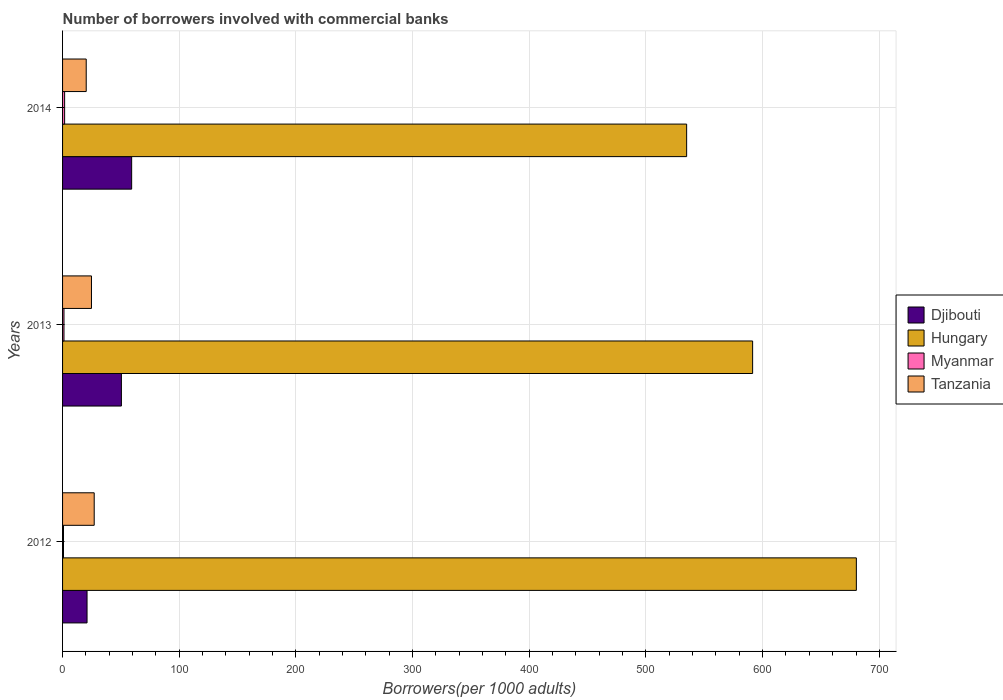How many bars are there on the 1st tick from the top?
Make the answer very short. 4. How many bars are there on the 3rd tick from the bottom?
Make the answer very short. 4. What is the label of the 1st group of bars from the top?
Your answer should be very brief. 2014. What is the number of borrowers involved with commercial banks in Myanmar in 2013?
Make the answer very short. 1.22. Across all years, what is the maximum number of borrowers involved with commercial banks in Djibouti?
Provide a succinct answer. 59.22. Across all years, what is the minimum number of borrowers involved with commercial banks in Tanzania?
Make the answer very short. 20.27. In which year was the number of borrowers involved with commercial banks in Tanzania maximum?
Provide a succinct answer. 2012. In which year was the number of borrowers involved with commercial banks in Djibouti minimum?
Your response must be concise. 2012. What is the total number of borrowers involved with commercial banks in Myanmar in the graph?
Your answer should be compact. 3.78. What is the difference between the number of borrowers involved with commercial banks in Tanzania in 2012 and that in 2014?
Your response must be concise. 6.85. What is the difference between the number of borrowers involved with commercial banks in Hungary in 2013 and the number of borrowers involved with commercial banks in Djibouti in 2012?
Your answer should be very brief. 570.44. What is the average number of borrowers involved with commercial banks in Tanzania per year?
Offer a terse response. 24.05. In the year 2013, what is the difference between the number of borrowers involved with commercial banks in Hungary and number of borrowers involved with commercial banks in Djibouti?
Offer a terse response. 540.99. What is the ratio of the number of borrowers involved with commercial banks in Djibouti in 2013 to that in 2014?
Offer a very short reply. 0.85. Is the number of borrowers involved with commercial banks in Hungary in 2013 less than that in 2014?
Your response must be concise. No. Is the difference between the number of borrowers involved with commercial banks in Hungary in 2012 and 2013 greater than the difference between the number of borrowers involved with commercial banks in Djibouti in 2012 and 2013?
Offer a terse response. Yes. What is the difference between the highest and the second highest number of borrowers involved with commercial banks in Hungary?
Offer a terse response. 88.9. What is the difference between the highest and the lowest number of borrowers involved with commercial banks in Djibouti?
Provide a short and direct response. 38.24. In how many years, is the number of borrowers involved with commercial banks in Hungary greater than the average number of borrowers involved with commercial banks in Hungary taken over all years?
Offer a very short reply. 1. Is the sum of the number of borrowers involved with commercial banks in Tanzania in 2012 and 2013 greater than the maximum number of borrowers involved with commercial banks in Hungary across all years?
Offer a very short reply. No. Is it the case that in every year, the sum of the number of borrowers involved with commercial banks in Hungary and number of borrowers involved with commercial banks in Myanmar is greater than the sum of number of borrowers involved with commercial banks in Djibouti and number of borrowers involved with commercial banks in Tanzania?
Offer a very short reply. Yes. What does the 2nd bar from the top in 2013 represents?
Give a very brief answer. Myanmar. What does the 3rd bar from the bottom in 2014 represents?
Provide a succinct answer. Myanmar. Is it the case that in every year, the sum of the number of borrowers involved with commercial banks in Myanmar and number of borrowers involved with commercial banks in Tanzania is greater than the number of borrowers involved with commercial banks in Hungary?
Keep it short and to the point. No. How many bars are there?
Give a very brief answer. 12. Are all the bars in the graph horizontal?
Offer a terse response. Yes. What is the difference between two consecutive major ticks on the X-axis?
Your answer should be compact. 100. Are the values on the major ticks of X-axis written in scientific E-notation?
Provide a succinct answer. No. Where does the legend appear in the graph?
Ensure brevity in your answer.  Center right. How are the legend labels stacked?
Keep it short and to the point. Vertical. What is the title of the graph?
Your answer should be compact. Number of borrowers involved with commercial banks. Does "Haiti" appear as one of the legend labels in the graph?
Provide a succinct answer. No. What is the label or title of the X-axis?
Offer a terse response. Borrowers(per 1000 adults). What is the Borrowers(per 1000 adults) in Djibouti in 2012?
Your answer should be compact. 20.98. What is the Borrowers(per 1000 adults) of Hungary in 2012?
Ensure brevity in your answer.  680.32. What is the Borrowers(per 1000 adults) of Myanmar in 2012?
Your answer should be compact. 0.8. What is the Borrowers(per 1000 adults) of Tanzania in 2012?
Your response must be concise. 27.12. What is the Borrowers(per 1000 adults) in Djibouti in 2013?
Keep it short and to the point. 50.43. What is the Borrowers(per 1000 adults) of Hungary in 2013?
Offer a terse response. 591.42. What is the Borrowers(per 1000 adults) of Myanmar in 2013?
Offer a very short reply. 1.22. What is the Borrowers(per 1000 adults) of Tanzania in 2013?
Offer a very short reply. 24.77. What is the Borrowers(per 1000 adults) in Djibouti in 2014?
Your answer should be very brief. 59.22. What is the Borrowers(per 1000 adults) of Hungary in 2014?
Make the answer very short. 534.85. What is the Borrowers(per 1000 adults) in Myanmar in 2014?
Your response must be concise. 1.77. What is the Borrowers(per 1000 adults) in Tanzania in 2014?
Provide a short and direct response. 20.27. Across all years, what is the maximum Borrowers(per 1000 adults) in Djibouti?
Your response must be concise. 59.22. Across all years, what is the maximum Borrowers(per 1000 adults) of Hungary?
Provide a short and direct response. 680.32. Across all years, what is the maximum Borrowers(per 1000 adults) in Myanmar?
Keep it short and to the point. 1.77. Across all years, what is the maximum Borrowers(per 1000 adults) in Tanzania?
Ensure brevity in your answer.  27.12. Across all years, what is the minimum Borrowers(per 1000 adults) of Djibouti?
Offer a terse response. 20.98. Across all years, what is the minimum Borrowers(per 1000 adults) in Hungary?
Provide a succinct answer. 534.85. Across all years, what is the minimum Borrowers(per 1000 adults) in Myanmar?
Your response must be concise. 0.8. Across all years, what is the minimum Borrowers(per 1000 adults) of Tanzania?
Your answer should be very brief. 20.27. What is the total Borrowers(per 1000 adults) of Djibouti in the graph?
Keep it short and to the point. 130.63. What is the total Borrowers(per 1000 adults) of Hungary in the graph?
Your answer should be compact. 1806.59. What is the total Borrowers(per 1000 adults) in Myanmar in the graph?
Provide a short and direct response. 3.78. What is the total Borrowers(per 1000 adults) in Tanzania in the graph?
Provide a short and direct response. 72.15. What is the difference between the Borrowers(per 1000 adults) in Djibouti in 2012 and that in 2013?
Provide a succinct answer. -29.45. What is the difference between the Borrowers(per 1000 adults) of Hungary in 2012 and that in 2013?
Your answer should be compact. 88.9. What is the difference between the Borrowers(per 1000 adults) in Myanmar in 2012 and that in 2013?
Offer a terse response. -0.42. What is the difference between the Borrowers(per 1000 adults) of Tanzania in 2012 and that in 2013?
Make the answer very short. 2.35. What is the difference between the Borrowers(per 1000 adults) of Djibouti in 2012 and that in 2014?
Your response must be concise. -38.24. What is the difference between the Borrowers(per 1000 adults) of Hungary in 2012 and that in 2014?
Your answer should be very brief. 145.46. What is the difference between the Borrowers(per 1000 adults) of Myanmar in 2012 and that in 2014?
Offer a very short reply. -0.97. What is the difference between the Borrowers(per 1000 adults) of Tanzania in 2012 and that in 2014?
Provide a succinct answer. 6.85. What is the difference between the Borrowers(per 1000 adults) of Djibouti in 2013 and that in 2014?
Ensure brevity in your answer.  -8.79. What is the difference between the Borrowers(per 1000 adults) in Hungary in 2013 and that in 2014?
Provide a succinct answer. 56.56. What is the difference between the Borrowers(per 1000 adults) of Myanmar in 2013 and that in 2014?
Provide a short and direct response. -0.55. What is the difference between the Borrowers(per 1000 adults) in Tanzania in 2013 and that in 2014?
Keep it short and to the point. 4.5. What is the difference between the Borrowers(per 1000 adults) in Djibouti in 2012 and the Borrowers(per 1000 adults) in Hungary in 2013?
Your answer should be very brief. -570.44. What is the difference between the Borrowers(per 1000 adults) in Djibouti in 2012 and the Borrowers(per 1000 adults) in Myanmar in 2013?
Give a very brief answer. 19.76. What is the difference between the Borrowers(per 1000 adults) in Djibouti in 2012 and the Borrowers(per 1000 adults) in Tanzania in 2013?
Ensure brevity in your answer.  -3.79. What is the difference between the Borrowers(per 1000 adults) in Hungary in 2012 and the Borrowers(per 1000 adults) in Myanmar in 2013?
Offer a terse response. 679.1. What is the difference between the Borrowers(per 1000 adults) in Hungary in 2012 and the Borrowers(per 1000 adults) in Tanzania in 2013?
Provide a short and direct response. 655.55. What is the difference between the Borrowers(per 1000 adults) of Myanmar in 2012 and the Borrowers(per 1000 adults) of Tanzania in 2013?
Provide a succinct answer. -23.97. What is the difference between the Borrowers(per 1000 adults) of Djibouti in 2012 and the Borrowers(per 1000 adults) of Hungary in 2014?
Your answer should be compact. -513.88. What is the difference between the Borrowers(per 1000 adults) of Djibouti in 2012 and the Borrowers(per 1000 adults) of Myanmar in 2014?
Your response must be concise. 19.21. What is the difference between the Borrowers(per 1000 adults) of Djibouti in 2012 and the Borrowers(per 1000 adults) of Tanzania in 2014?
Make the answer very short. 0.71. What is the difference between the Borrowers(per 1000 adults) in Hungary in 2012 and the Borrowers(per 1000 adults) in Myanmar in 2014?
Your answer should be very brief. 678.55. What is the difference between the Borrowers(per 1000 adults) in Hungary in 2012 and the Borrowers(per 1000 adults) in Tanzania in 2014?
Provide a short and direct response. 660.05. What is the difference between the Borrowers(per 1000 adults) of Myanmar in 2012 and the Borrowers(per 1000 adults) of Tanzania in 2014?
Provide a succinct answer. -19.47. What is the difference between the Borrowers(per 1000 adults) in Djibouti in 2013 and the Borrowers(per 1000 adults) in Hungary in 2014?
Provide a short and direct response. -484.43. What is the difference between the Borrowers(per 1000 adults) of Djibouti in 2013 and the Borrowers(per 1000 adults) of Myanmar in 2014?
Ensure brevity in your answer.  48.66. What is the difference between the Borrowers(per 1000 adults) of Djibouti in 2013 and the Borrowers(per 1000 adults) of Tanzania in 2014?
Ensure brevity in your answer.  30.16. What is the difference between the Borrowers(per 1000 adults) of Hungary in 2013 and the Borrowers(per 1000 adults) of Myanmar in 2014?
Your response must be concise. 589.65. What is the difference between the Borrowers(per 1000 adults) of Hungary in 2013 and the Borrowers(per 1000 adults) of Tanzania in 2014?
Your response must be concise. 571.15. What is the difference between the Borrowers(per 1000 adults) of Myanmar in 2013 and the Borrowers(per 1000 adults) of Tanzania in 2014?
Give a very brief answer. -19.05. What is the average Borrowers(per 1000 adults) in Djibouti per year?
Provide a succinct answer. 43.54. What is the average Borrowers(per 1000 adults) of Hungary per year?
Make the answer very short. 602.2. What is the average Borrowers(per 1000 adults) in Myanmar per year?
Keep it short and to the point. 1.26. What is the average Borrowers(per 1000 adults) of Tanzania per year?
Keep it short and to the point. 24.05. In the year 2012, what is the difference between the Borrowers(per 1000 adults) of Djibouti and Borrowers(per 1000 adults) of Hungary?
Keep it short and to the point. -659.34. In the year 2012, what is the difference between the Borrowers(per 1000 adults) in Djibouti and Borrowers(per 1000 adults) in Myanmar?
Provide a succinct answer. 20.18. In the year 2012, what is the difference between the Borrowers(per 1000 adults) of Djibouti and Borrowers(per 1000 adults) of Tanzania?
Provide a short and direct response. -6.14. In the year 2012, what is the difference between the Borrowers(per 1000 adults) in Hungary and Borrowers(per 1000 adults) in Myanmar?
Provide a succinct answer. 679.52. In the year 2012, what is the difference between the Borrowers(per 1000 adults) in Hungary and Borrowers(per 1000 adults) in Tanzania?
Give a very brief answer. 653.2. In the year 2012, what is the difference between the Borrowers(per 1000 adults) in Myanmar and Borrowers(per 1000 adults) in Tanzania?
Keep it short and to the point. -26.32. In the year 2013, what is the difference between the Borrowers(per 1000 adults) of Djibouti and Borrowers(per 1000 adults) of Hungary?
Offer a very short reply. -540.99. In the year 2013, what is the difference between the Borrowers(per 1000 adults) of Djibouti and Borrowers(per 1000 adults) of Myanmar?
Make the answer very short. 49.21. In the year 2013, what is the difference between the Borrowers(per 1000 adults) in Djibouti and Borrowers(per 1000 adults) in Tanzania?
Offer a terse response. 25.66. In the year 2013, what is the difference between the Borrowers(per 1000 adults) in Hungary and Borrowers(per 1000 adults) in Myanmar?
Provide a short and direct response. 590.2. In the year 2013, what is the difference between the Borrowers(per 1000 adults) in Hungary and Borrowers(per 1000 adults) in Tanzania?
Provide a short and direct response. 566.65. In the year 2013, what is the difference between the Borrowers(per 1000 adults) of Myanmar and Borrowers(per 1000 adults) of Tanzania?
Provide a short and direct response. -23.55. In the year 2014, what is the difference between the Borrowers(per 1000 adults) in Djibouti and Borrowers(per 1000 adults) in Hungary?
Offer a terse response. -475.63. In the year 2014, what is the difference between the Borrowers(per 1000 adults) in Djibouti and Borrowers(per 1000 adults) in Myanmar?
Offer a terse response. 57.45. In the year 2014, what is the difference between the Borrowers(per 1000 adults) of Djibouti and Borrowers(per 1000 adults) of Tanzania?
Your answer should be compact. 38.95. In the year 2014, what is the difference between the Borrowers(per 1000 adults) in Hungary and Borrowers(per 1000 adults) in Myanmar?
Keep it short and to the point. 533.09. In the year 2014, what is the difference between the Borrowers(per 1000 adults) in Hungary and Borrowers(per 1000 adults) in Tanzania?
Your response must be concise. 514.59. In the year 2014, what is the difference between the Borrowers(per 1000 adults) in Myanmar and Borrowers(per 1000 adults) in Tanzania?
Ensure brevity in your answer.  -18.5. What is the ratio of the Borrowers(per 1000 adults) of Djibouti in 2012 to that in 2013?
Your answer should be compact. 0.42. What is the ratio of the Borrowers(per 1000 adults) in Hungary in 2012 to that in 2013?
Make the answer very short. 1.15. What is the ratio of the Borrowers(per 1000 adults) of Myanmar in 2012 to that in 2013?
Give a very brief answer. 0.65. What is the ratio of the Borrowers(per 1000 adults) of Tanzania in 2012 to that in 2013?
Offer a terse response. 1.09. What is the ratio of the Borrowers(per 1000 adults) of Djibouti in 2012 to that in 2014?
Keep it short and to the point. 0.35. What is the ratio of the Borrowers(per 1000 adults) in Hungary in 2012 to that in 2014?
Ensure brevity in your answer.  1.27. What is the ratio of the Borrowers(per 1000 adults) of Myanmar in 2012 to that in 2014?
Ensure brevity in your answer.  0.45. What is the ratio of the Borrowers(per 1000 adults) of Tanzania in 2012 to that in 2014?
Provide a succinct answer. 1.34. What is the ratio of the Borrowers(per 1000 adults) in Djibouti in 2013 to that in 2014?
Give a very brief answer. 0.85. What is the ratio of the Borrowers(per 1000 adults) in Hungary in 2013 to that in 2014?
Offer a terse response. 1.11. What is the ratio of the Borrowers(per 1000 adults) of Myanmar in 2013 to that in 2014?
Your answer should be very brief. 0.69. What is the ratio of the Borrowers(per 1000 adults) in Tanzania in 2013 to that in 2014?
Keep it short and to the point. 1.22. What is the difference between the highest and the second highest Borrowers(per 1000 adults) in Djibouti?
Offer a terse response. 8.79. What is the difference between the highest and the second highest Borrowers(per 1000 adults) of Hungary?
Offer a terse response. 88.9. What is the difference between the highest and the second highest Borrowers(per 1000 adults) of Myanmar?
Offer a very short reply. 0.55. What is the difference between the highest and the second highest Borrowers(per 1000 adults) in Tanzania?
Make the answer very short. 2.35. What is the difference between the highest and the lowest Borrowers(per 1000 adults) in Djibouti?
Make the answer very short. 38.24. What is the difference between the highest and the lowest Borrowers(per 1000 adults) of Hungary?
Offer a very short reply. 145.46. What is the difference between the highest and the lowest Borrowers(per 1000 adults) in Myanmar?
Provide a short and direct response. 0.97. What is the difference between the highest and the lowest Borrowers(per 1000 adults) in Tanzania?
Your answer should be compact. 6.85. 